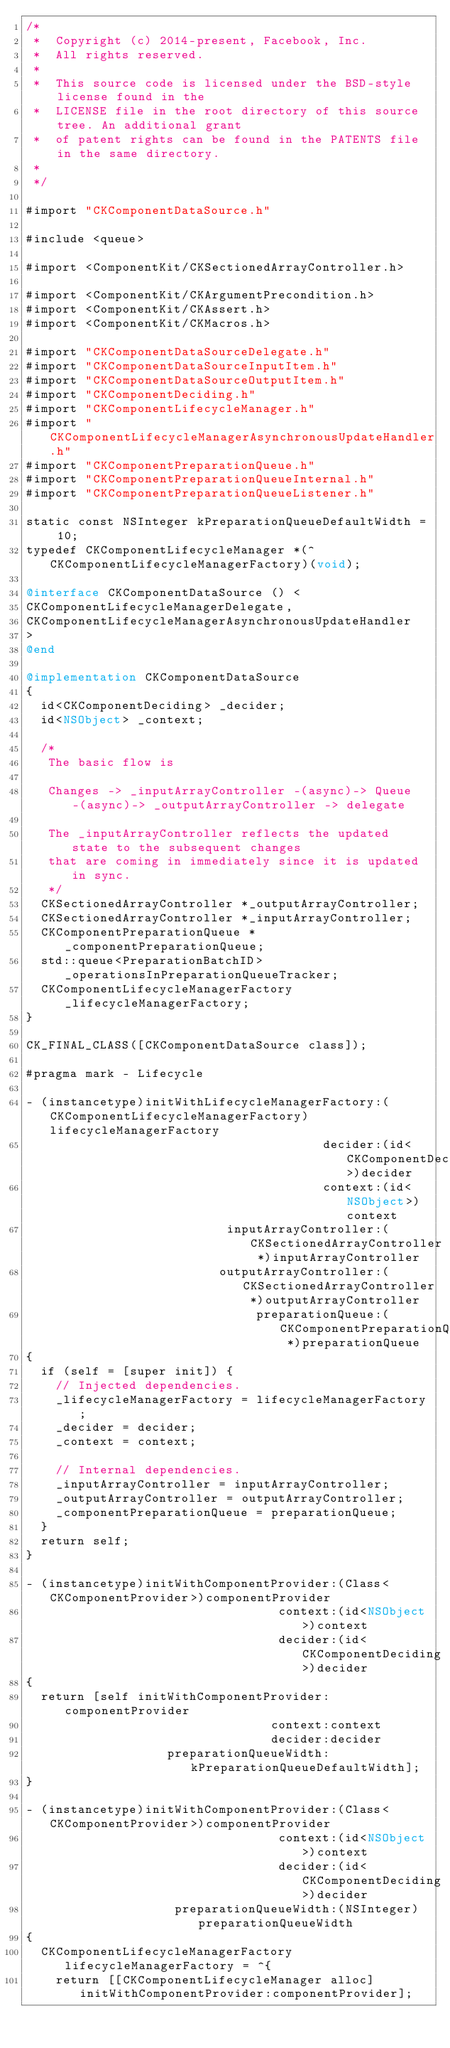Convert code to text. <code><loc_0><loc_0><loc_500><loc_500><_ObjectiveC_>/*
 *  Copyright (c) 2014-present, Facebook, Inc.
 *  All rights reserved.
 *
 *  This source code is licensed under the BSD-style license found in the
 *  LICENSE file in the root directory of this source tree. An additional grant
 *  of patent rights can be found in the PATENTS file in the same directory.
 *
 */

#import "CKComponentDataSource.h"

#include <queue>

#import <ComponentKit/CKSectionedArrayController.h>

#import <ComponentKit/CKArgumentPrecondition.h>
#import <ComponentKit/CKAssert.h>
#import <ComponentKit/CKMacros.h>

#import "CKComponentDataSourceDelegate.h"
#import "CKComponentDataSourceInputItem.h"
#import "CKComponentDataSourceOutputItem.h"
#import "CKComponentDeciding.h"
#import "CKComponentLifecycleManager.h"
#import "CKComponentLifecycleManagerAsynchronousUpdateHandler.h"
#import "CKComponentPreparationQueue.h"
#import "CKComponentPreparationQueueInternal.h"
#import "CKComponentPreparationQueueListener.h"

static const NSInteger kPreparationQueueDefaultWidth = 10;
typedef CKComponentLifecycleManager *(^CKComponentLifecycleManagerFactory)(void);

@interface CKComponentDataSource () <
CKComponentLifecycleManagerDelegate,
CKComponentLifecycleManagerAsynchronousUpdateHandler
>
@end

@implementation CKComponentDataSource
{
  id<CKComponentDeciding> _decider;
  id<NSObject> _context;

  /*
   The basic flow is

   Changes -> _inputArrayController -(async)-> Queue -(async)-> _outputArrayController -> delegate

   The _inputArrayController reflects the updated state to the subsequent changes
   that are coming in immediately since it is updated in sync.
   */
  CKSectionedArrayController *_outputArrayController;
  CKSectionedArrayController *_inputArrayController;
  CKComponentPreparationQueue *_componentPreparationQueue;
  std::queue<PreparationBatchID> _operationsInPreparationQueueTracker;
  CKComponentLifecycleManagerFactory _lifecycleManagerFactory;
}

CK_FINAL_CLASS([CKComponentDataSource class]);

#pragma mark - Lifecycle

- (instancetype)initWithLifecycleManagerFactory:(CKComponentLifecycleManagerFactory)lifecycleManagerFactory
                                        decider:(id<CKComponentDeciding>)decider
                                        context:(id<NSObject>)context
                           inputArrayController:(CKSectionedArrayController *)inputArrayController
                          outputArrayController:(CKSectionedArrayController *)outputArrayController
                               preparationQueue:(CKComponentPreparationQueue *)preparationQueue
{
  if (self = [super init]) {
    // Injected dependencies.
    _lifecycleManagerFactory = lifecycleManagerFactory;
    _decider = decider;
    _context = context;

    // Internal dependencies.
    _inputArrayController = inputArrayController;
    _outputArrayController = outputArrayController;
    _componentPreparationQueue = preparationQueue;
  }
  return self;
}

- (instancetype)initWithComponentProvider:(Class<CKComponentProvider>)componentProvider
                                  context:(id<NSObject>)context
                                  decider:(id<CKComponentDeciding>)decider
{
  return [self initWithComponentProvider:componentProvider
                                 context:context
                                 decider:decider
                   preparationQueueWidth:kPreparationQueueDefaultWidth];
}

- (instancetype)initWithComponentProvider:(Class<CKComponentProvider>)componentProvider
                                  context:(id<NSObject>)context
                                  decider:(id<CKComponentDeciding>)decider
                    preparationQueueWidth:(NSInteger)preparationQueueWidth
{
  CKComponentLifecycleManagerFactory lifecycleManagerFactory = ^{
    return [[CKComponentLifecycleManager alloc] initWithComponentProvider:componentProvider];</code> 